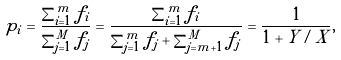Convert formula to latex. <formula><loc_0><loc_0><loc_500><loc_500>p _ { i } = \frac { \sum _ { i = 1 } ^ { m } f _ { i } } { \sum _ { j = 1 } ^ { M } f _ { j } } = \frac { \sum _ { i = 1 } ^ { m } f _ { i } } { \sum _ { j = 1 } ^ { m } f _ { j } + \sum _ { j = m + 1 } ^ { M } f _ { j } } = \frac { 1 } { 1 + Y / X } ,</formula> 